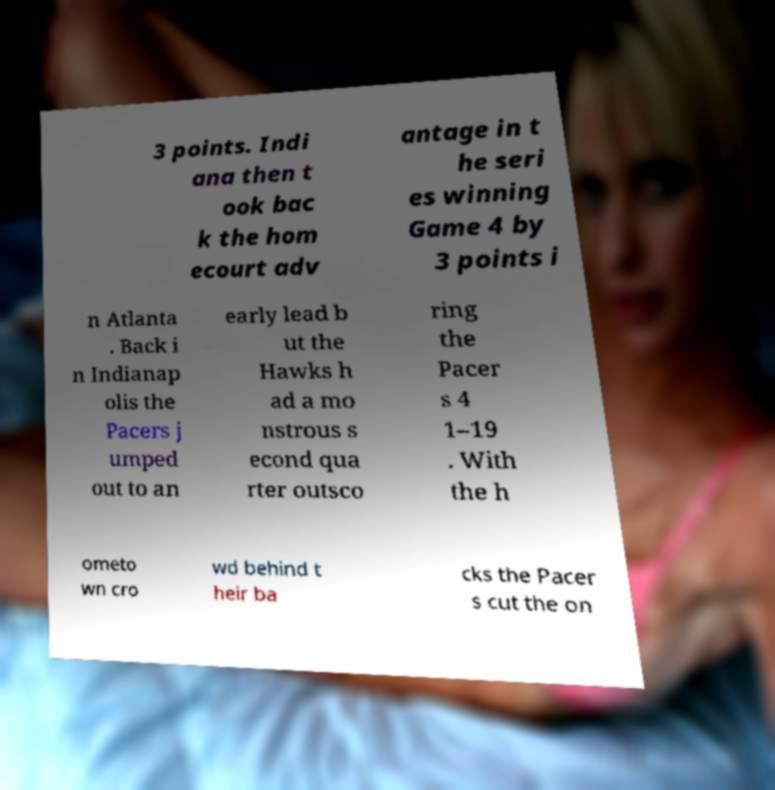What messages or text are displayed in this image? I need them in a readable, typed format. 3 points. Indi ana then t ook bac k the hom ecourt adv antage in t he seri es winning Game 4 by 3 points i n Atlanta . Back i n Indianap olis the Pacers j umped out to an early lead b ut the Hawks h ad a mo nstrous s econd qua rter outsco ring the Pacer s 4 1–19 . With the h ometo wn cro wd behind t heir ba cks the Pacer s cut the on 